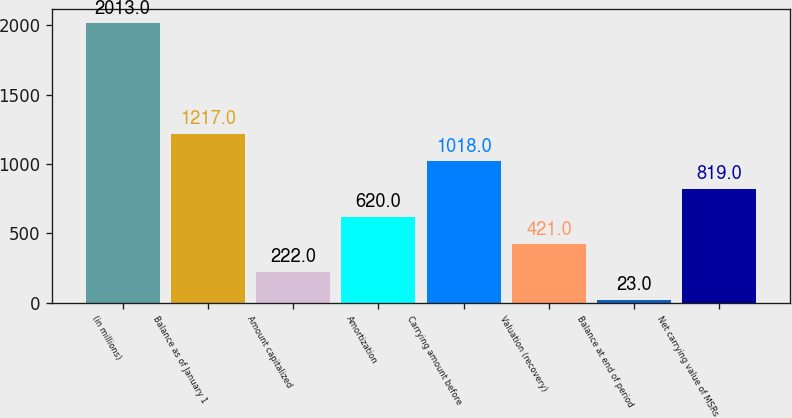Convert chart to OTSL. <chart><loc_0><loc_0><loc_500><loc_500><bar_chart><fcel>(in millions)<fcel>Balance as of January 1<fcel>Amount capitalized<fcel>Amortization<fcel>Carrying amount before<fcel>Valuation (recovery)<fcel>Balance at end of period<fcel>Net carrying value of MSRs<nl><fcel>2013<fcel>1217<fcel>222<fcel>620<fcel>1018<fcel>421<fcel>23<fcel>819<nl></chart> 